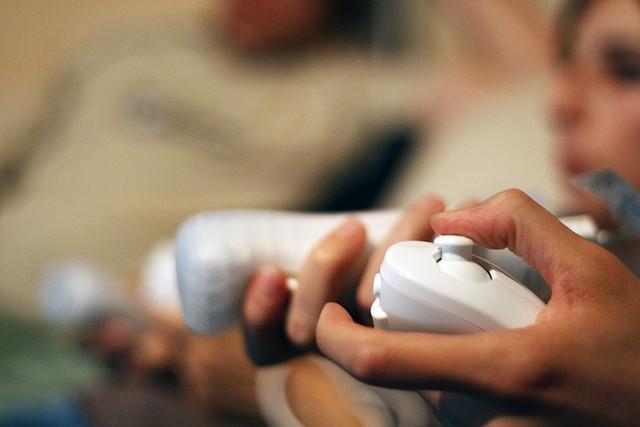Is there a lot of detail in this picture?
Write a very short answer. No. What is the level the man is holding with his thumb called?
Give a very brief answer. Joy stick. Are all devices in focus?
Concise answer only. No. 